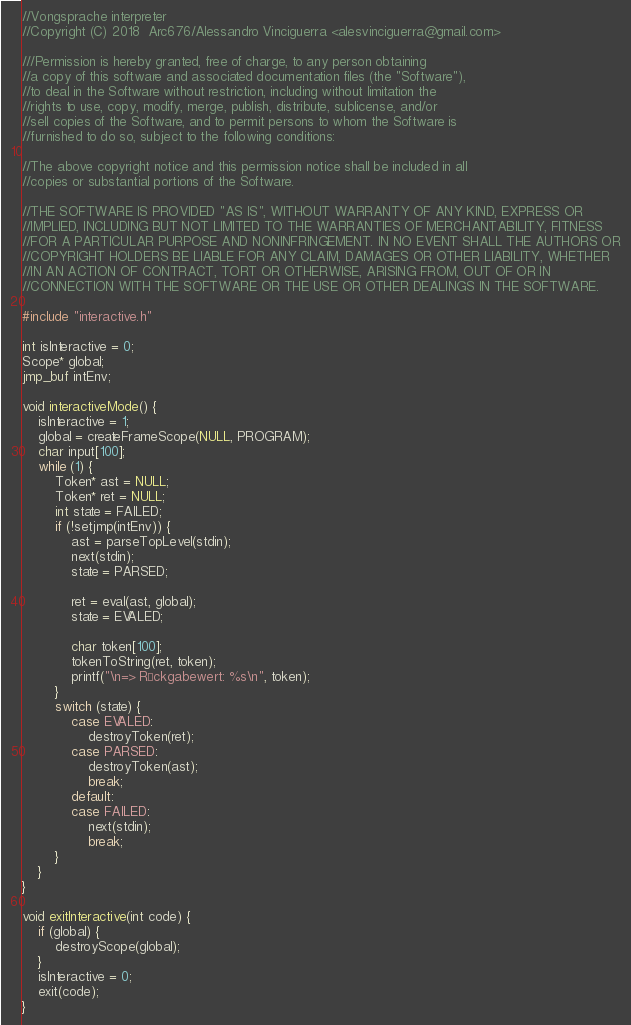<code> <loc_0><loc_0><loc_500><loc_500><_C_>//Vongsprache interpreter
//Copyright (C) 2018  Arc676/Alessandro Vinciguerra <alesvinciguerra@gmail.com>

///Permission is hereby granted, free of charge, to any person obtaining
//a copy of this software and associated documentation files (the "Software"),
//to deal in the Software without restriction, including without limitation the
//rights to use, copy, modify, merge, publish, distribute, sublicense, and/or
//sell copies of the Software, and to permit persons to whom the Software is
//furnished to do so, subject to the following conditions:

//The above copyright notice and this permission notice shall be included in all
//copies or substantial portions of the Software.

//THE SOFTWARE IS PROVIDED "AS IS", WITHOUT WARRANTY OF ANY KIND, EXPRESS OR
//IMPLIED, INCLUDING BUT NOT LIMITED TO THE WARRANTIES OF MERCHANTABILITY, FITNESS
//FOR A PARTICULAR PURPOSE AND NONINFRINGEMENT. IN NO EVENT SHALL THE AUTHORS OR
//COPYRIGHT HOLDERS BE LIABLE FOR ANY CLAIM, DAMAGES OR OTHER LIABILITY, WHETHER
//IN AN ACTION OF CONTRACT, TORT OR OTHERWISE, ARISING FROM, OUT OF OR IN
//CONNECTION WITH THE SOFTWARE OR THE USE OR OTHER DEALINGS IN THE SOFTWARE.

#include "interactive.h"

int isInteractive = 0;
Scope* global;
jmp_buf intEnv;

void interactiveMode() {
	isInteractive = 1;
	global = createFrameScope(NULL, PROGRAM);
	char input[100];
	while (1) {
		Token* ast = NULL;
		Token* ret = NULL;
		int state = FAILED;
		if (!setjmp(intEnv)) {
			ast = parseTopLevel(stdin);
			next(stdin);
			state = PARSED;

			ret = eval(ast, global);
			state = EVALED;

			char token[100];
			tokenToString(ret, token);
			printf("\n=> Rückgabewert: %s\n", token);
		}
		switch (state) {
			case EVALED:
				destroyToken(ret);
			case PARSED:
				destroyToken(ast);
				break;
			default:
			case FAILED:
				next(stdin);
				break;
		}
	}
}

void exitInteractive(int code) {
	if (global) {
		destroyScope(global);
	}
	isInteractive = 0;
	exit(code);
}
</code> 